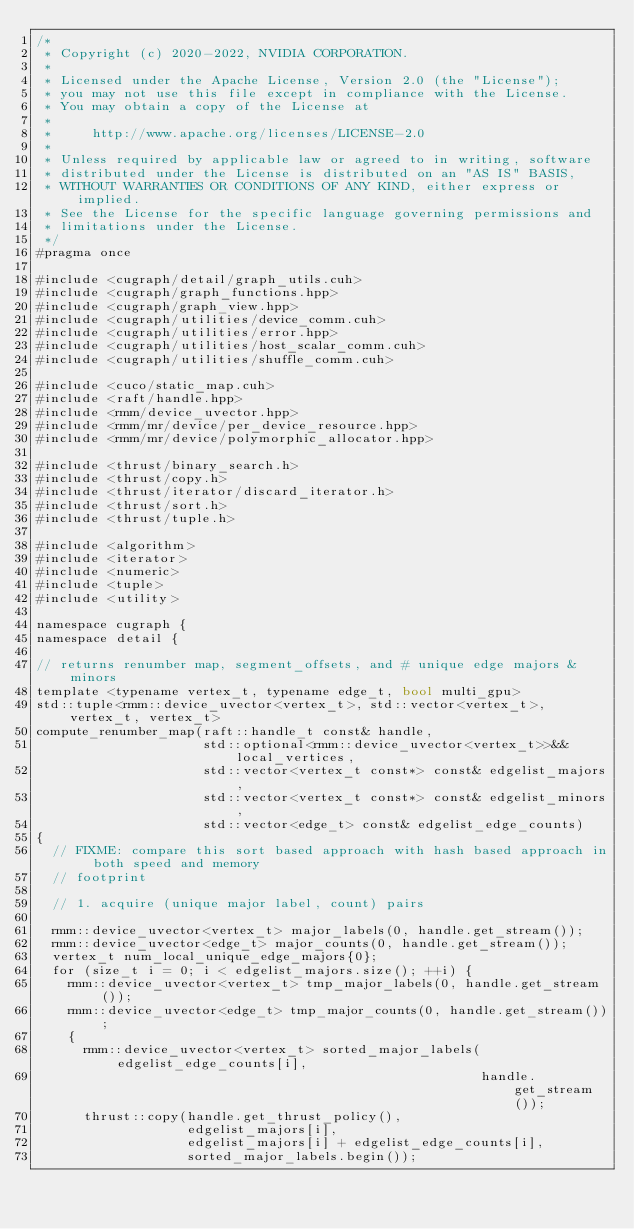<code> <loc_0><loc_0><loc_500><loc_500><_Cuda_>/*
 * Copyright (c) 2020-2022, NVIDIA CORPORATION.
 *
 * Licensed under the Apache License, Version 2.0 (the "License");
 * you may not use this file except in compliance with the License.
 * You may obtain a copy of the License at
 *
 *     http://www.apache.org/licenses/LICENSE-2.0
 *
 * Unless required by applicable law or agreed to in writing, software
 * distributed under the License is distributed on an "AS IS" BASIS,
 * WITHOUT WARRANTIES OR CONDITIONS OF ANY KIND, either express or implied.
 * See the License for the specific language governing permissions and
 * limitations under the License.
 */
#pragma once

#include <cugraph/detail/graph_utils.cuh>
#include <cugraph/graph_functions.hpp>
#include <cugraph/graph_view.hpp>
#include <cugraph/utilities/device_comm.cuh>
#include <cugraph/utilities/error.hpp>
#include <cugraph/utilities/host_scalar_comm.cuh>
#include <cugraph/utilities/shuffle_comm.cuh>

#include <cuco/static_map.cuh>
#include <raft/handle.hpp>
#include <rmm/device_uvector.hpp>
#include <rmm/mr/device/per_device_resource.hpp>
#include <rmm/mr/device/polymorphic_allocator.hpp>

#include <thrust/binary_search.h>
#include <thrust/copy.h>
#include <thrust/iterator/discard_iterator.h>
#include <thrust/sort.h>
#include <thrust/tuple.h>

#include <algorithm>
#include <iterator>
#include <numeric>
#include <tuple>
#include <utility>

namespace cugraph {
namespace detail {

// returns renumber map, segment_offsets, and # unique edge majors & minors
template <typename vertex_t, typename edge_t, bool multi_gpu>
std::tuple<rmm::device_uvector<vertex_t>, std::vector<vertex_t>, vertex_t, vertex_t>
compute_renumber_map(raft::handle_t const& handle,
                     std::optional<rmm::device_uvector<vertex_t>>&& local_vertices,
                     std::vector<vertex_t const*> const& edgelist_majors,
                     std::vector<vertex_t const*> const& edgelist_minors,
                     std::vector<edge_t> const& edgelist_edge_counts)
{
  // FIXME: compare this sort based approach with hash based approach in both speed and memory
  // footprint

  // 1. acquire (unique major label, count) pairs

  rmm::device_uvector<vertex_t> major_labels(0, handle.get_stream());
  rmm::device_uvector<edge_t> major_counts(0, handle.get_stream());
  vertex_t num_local_unique_edge_majors{0};
  for (size_t i = 0; i < edgelist_majors.size(); ++i) {
    rmm::device_uvector<vertex_t> tmp_major_labels(0, handle.get_stream());
    rmm::device_uvector<edge_t> tmp_major_counts(0, handle.get_stream());
    {
      rmm::device_uvector<vertex_t> sorted_major_labels(edgelist_edge_counts[i],
                                                        handle.get_stream());
      thrust::copy(handle.get_thrust_policy(),
                   edgelist_majors[i],
                   edgelist_majors[i] + edgelist_edge_counts[i],
                   sorted_major_labels.begin());</code> 